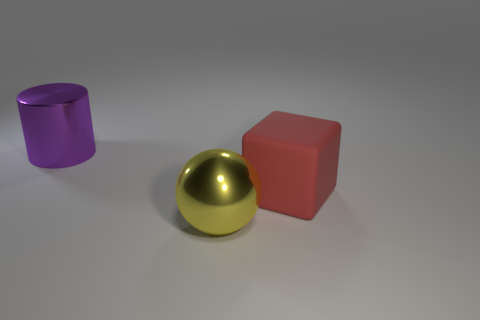How many other objects are the same size as the red matte thing?
Offer a terse response. 2. What size is the yellow metallic object?
Provide a succinct answer. Large. Are the big yellow sphere and the object that is to the right of the metallic sphere made of the same material?
Make the answer very short. No. There is a red cube that is the same size as the yellow sphere; what is its material?
Make the answer very short. Rubber. There is a metal object that is behind the metal sphere; how big is it?
Your response must be concise. Large. Is the size of the metal thing that is on the left side of the shiny ball the same as the object to the right of the sphere?
Your response must be concise. Yes. How many big cylinders are made of the same material as the large block?
Provide a succinct answer. 0. What is the color of the large rubber block?
Keep it short and to the point. Red. Are there any large yellow objects behind the block?
Your answer should be compact. No. How many matte objects are the same color as the big matte cube?
Keep it short and to the point. 0. 